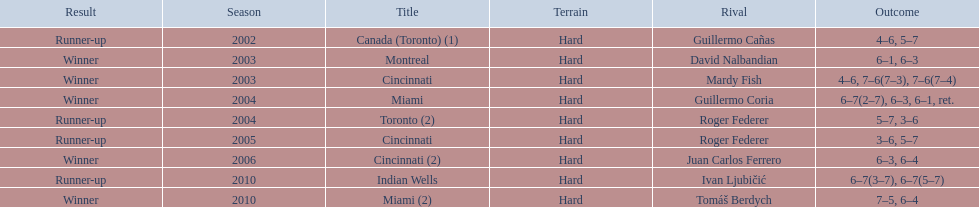How many total wins has he had? 5. 